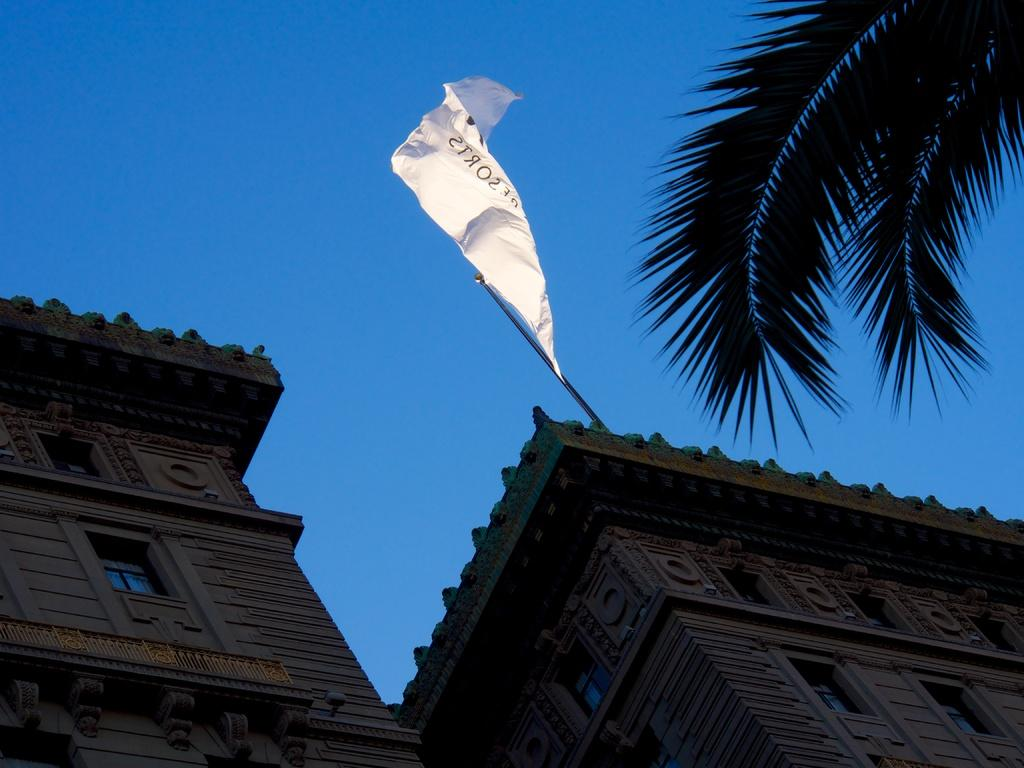What type of structures are present in the image? There are buildings with windows in the image. Can you describe any specific features of these buildings? One of the buildings has a flag with a pole. What can be seen in the right corner of the image? Coconut leaves are visible in the right corner of the image. What is visible in the background of the image? The sky is visible in the background of the image. What type of lettuce is growing in the image? There is no lettuce present in the image. What year is depicted in the image? The image does not depict a specific year; it is a static scene. Can you tell me how many deaths occurred in the image? There are no deaths depicted in the image; it is a scene of buildings, a flag, coconut leaves, and the sky. 